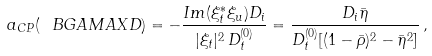Convert formula to latex. <formula><loc_0><loc_0><loc_500><loc_500>a _ { C P } ( \ B G A M A X D ) = - \frac { I m ( \xi _ { t } ^ { * } \xi _ { u } ) D _ { i } } { | \xi _ { t } | ^ { 2 } \, D _ { t } ^ { ( 0 ) } } = \frac { D _ { i } \bar { \eta } } { D _ { t } ^ { ( 0 ) } [ ( 1 - \bar { \rho } ) ^ { 2 } - \bar { \eta } ^ { 2 } ] } \, ,</formula> 